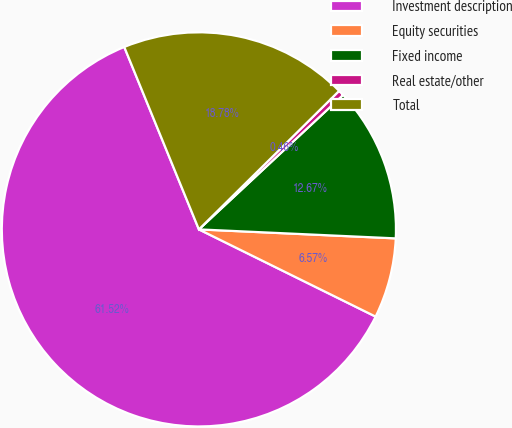Convert chart. <chart><loc_0><loc_0><loc_500><loc_500><pie_chart><fcel>Investment description<fcel>Equity securities<fcel>Fixed income<fcel>Real estate/other<fcel>Total<nl><fcel>61.53%<fcel>6.57%<fcel>12.67%<fcel>0.46%<fcel>18.78%<nl></chart> 